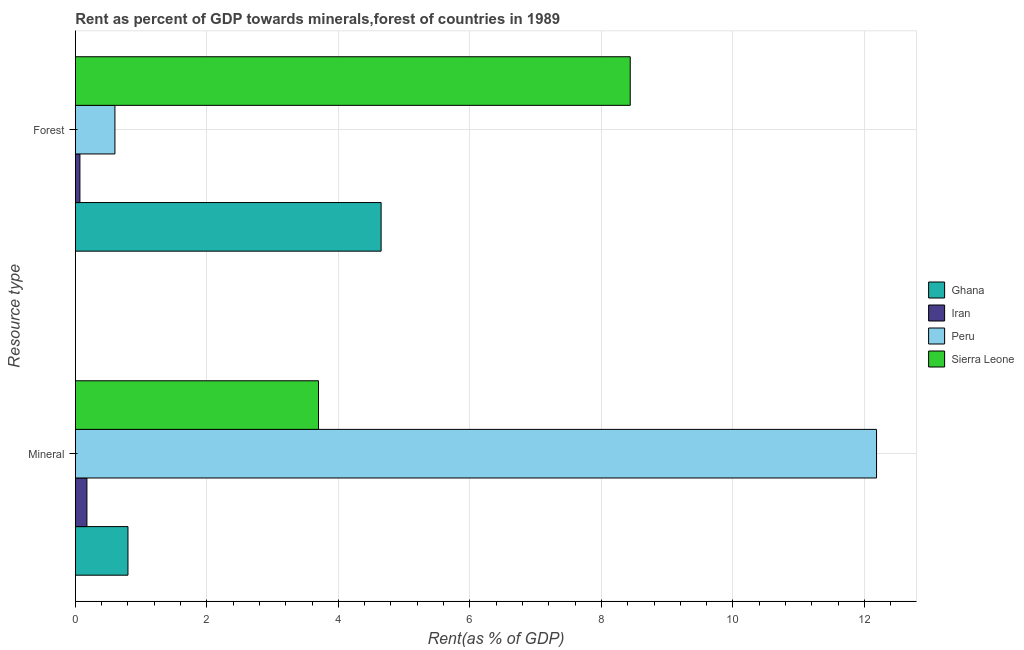How many groups of bars are there?
Provide a succinct answer. 2. What is the label of the 1st group of bars from the top?
Your answer should be very brief. Forest. What is the mineral rent in Sierra Leone?
Offer a terse response. 3.7. Across all countries, what is the maximum mineral rent?
Your answer should be very brief. 12.18. Across all countries, what is the minimum mineral rent?
Your answer should be very brief. 0.18. In which country was the forest rent minimum?
Provide a succinct answer. Iran. What is the total mineral rent in the graph?
Provide a short and direct response. 16.86. What is the difference between the forest rent in Peru and that in Iran?
Your response must be concise. 0.53. What is the difference between the forest rent in Sierra Leone and the mineral rent in Peru?
Offer a very short reply. -3.75. What is the average mineral rent per country?
Make the answer very short. 4.21. What is the difference between the forest rent and mineral rent in Peru?
Your response must be concise. -11.58. In how many countries, is the forest rent greater than 2 %?
Keep it short and to the point. 2. What is the ratio of the forest rent in Ghana to that in Sierra Leone?
Provide a succinct answer. 0.55. Is the mineral rent in Iran less than that in Ghana?
Offer a very short reply. Yes. What does the 3rd bar from the top in Mineral represents?
Your answer should be compact. Iran. What does the 2nd bar from the bottom in Mineral represents?
Keep it short and to the point. Iran. How many countries are there in the graph?
Offer a terse response. 4. What is the difference between two consecutive major ticks on the X-axis?
Keep it short and to the point. 2. Are the values on the major ticks of X-axis written in scientific E-notation?
Keep it short and to the point. No. Does the graph contain grids?
Your answer should be very brief. Yes. How many legend labels are there?
Your response must be concise. 4. What is the title of the graph?
Offer a very short reply. Rent as percent of GDP towards minerals,forest of countries in 1989. What is the label or title of the X-axis?
Your answer should be compact. Rent(as % of GDP). What is the label or title of the Y-axis?
Provide a succinct answer. Resource type. What is the Rent(as % of GDP) of Ghana in Mineral?
Offer a very short reply. 0.8. What is the Rent(as % of GDP) of Iran in Mineral?
Your response must be concise. 0.18. What is the Rent(as % of GDP) in Peru in Mineral?
Your answer should be very brief. 12.18. What is the Rent(as % of GDP) in Sierra Leone in Mineral?
Offer a very short reply. 3.7. What is the Rent(as % of GDP) of Ghana in Forest?
Offer a terse response. 4.65. What is the Rent(as % of GDP) in Iran in Forest?
Give a very brief answer. 0.07. What is the Rent(as % of GDP) in Peru in Forest?
Ensure brevity in your answer.  0.6. What is the Rent(as % of GDP) in Sierra Leone in Forest?
Your response must be concise. 8.44. Across all Resource type, what is the maximum Rent(as % of GDP) of Ghana?
Your answer should be very brief. 4.65. Across all Resource type, what is the maximum Rent(as % of GDP) of Iran?
Keep it short and to the point. 0.18. Across all Resource type, what is the maximum Rent(as % of GDP) of Peru?
Your answer should be compact. 12.18. Across all Resource type, what is the maximum Rent(as % of GDP) of Sierra Leone?
Your answer should be compact. 8.44. Across all Resource type, what is the minimum Rent(as % of GDP) in Ghana?
Ensure brevity in your answer.  0.8. Across all Resource type, what is the minimum Rent(as % of GDP) in Iran?
Offer a very short reply. 0.07. Across all Resource type, what is the minimum Rent(as % of GDP) of Peru?
Offer a very short reply. 0.6. Across all Resource type, what is the minimum Rent(as % of GDP) in Sierra Leone?
Your answer should be very brief. 3.7. What is the total Rent(as % of GDP) of Ghana in the graph?
Your response must be concise. 5.45. What is the total Rent(as % of GDP) in Iran in the graph?
Keep it short and to the point. 0.25. What is the total Rent(as % of GDP) of Peru in the graph?
Give a very brief answer. 12.79. What is the total Rent(as % of GDP) of Sierra Leone in the graph?
Make the answer very short. 12.14. What is the difference between the Rent(as % of GDP) in Ghana in Mineral and that in Forest?
Your answer should be compact. -3.85. What is the difference between the Rent(as % of GDP) in Iran in Mineral and that in Forest?
Ensure brevity in your answer.  0.11. What is the difference between the Rent(as % of GDP) of Peru in Mineral and that in Forest?
Your answer should be very brief. 11.58. What is the difference between the Rent(as % of GDP) in Sierra Leone in Mineral and that in Forest?
Your response must be concise. -4.74. What is the difference between the Rent(as % of GDP) of Ghana in Mineral and the Rent(as % of GDP) of Iran in Forest?
Give a very brief answer. 0.73. What is the difference between the Rent(as % of GDP) in Ghana in Mineral and the Rent(as % of GDP) in Peru in Forest?
Offer a very short reply. 0.2. What is the difference between the Rent(as % of GDP) of Ghana in Mineral and the Rent(as % of GDP) of Sierra Leone in Forest?
Your answer should be very brief. -7.64. What is the difference between the Rent(as % of GDP) of Iran in Mineral and the Rent(as % of GDP) of Peru in Forest?
Make the answer very short. -0.43. What is the difference between the Rent(as % of GDP) in Iran in Mineral and the Rent(as % of GDP) in Sierra Leone in Forest?
Give a very brief answer. -8.26. What is the difference between the Rent(as % of GDP) in Peru in Mineral and the Rent(as % of GDP) in Sierra Leone in Forest?
Make the answer very short. 3.75. What is the average Rent(as % of GDP) of Ghana per Resource type?
Provide a succinct answer. 2.73. What is the average Rent(as % of GDP) in Iran per Resource type?
Offer a terse response. 0.12. What is the average Rent(as % of GDP) in Peru per Resource type?
Keep it short and to the point. 6.39. What is the average Rent(as % of GDP) of Sierra Leone per Resource type?
Ensure brevity in your answer.  6.07. What is the difference between the Rent(as % of GDP) of Ghana and Rent(as % of GDP) of Iran in Mineral?
Keep it short and to the point. 0.62. What is the difference between the Rent(as % of GDP) of Ghana and Rent(as % of GDP) of Peru in Mineral?
Offer a terse response. -11.38. What is the difference between the Rent(as % of GDP) of Ghana and Rent(as % of GDP) of Sierra Leone in Mineral?
Provide a short and direct response. -2.9. What is the difference between the Rent(as % of GDP) of Iran and Rent(as % of GDP) of Peru in Mineral?
Give a very brief answer. -12.01. What is the difference between the Rent(as % of GDP) of Iran and Rent(as % of GDP) of Sierra Leone in Mineral?
Ensure brevity in your answer.  -3.52. What is the difference between the Rent(as % of GDP) in Peru and Rent(as % of GDP) in Sierra Leone in Mineral?
Give a very brief answer. 8.49. What is the difference between the Rent(as % of GDP) in Ghana and Rent(as % of GDP) in Iran in Forest?
Your response must be concise. 4.58. What is the difference between the Rent(as % of GDP) in Ghana and Rent(as % of GDP) in Peru in Forest?
Give a very brief answer. 4.05. What is the difference between the Rent(as % of GDP) in Ghana and Rent(as % of GDP) in Sierra Leone in Forest?
Ensure brevity in your answer.  -3.79. What is the difference between the Rent(as % of GDP) in Iran and Rent(as % of GDP) in Peru in Forest?
Provide a short and direct response. -0.53. What is the difference between the Rent(as % of GDP) in Iran and Rent(as % of GDP) in Sierra Leone in Forest?
Make the answer very short. -8.37. What is the difference between the Rent(as % of GDP) of Peru and Rent(as % of GDP) of Sierra Leone in Forest?
Provide a succinct answer. -7.84. What is the ratio of the Rent(as % of GDP) in Ghana in Mineral to that in Forest?
Your answer should be compact. 0.17. What is the ratio of the Rent(as % of GDP) of Iran in Mineral to that in Forest?
Ensure brevity in your answer.  2.51. What is the ratio of the Rent(as % of GDP) of Peru in Mineral to that in Forest?
Your answer should be compact. 20.22. What is the ratio of the Rent(as % of GDP) of Sierra Leone in Mineral to that in Forest?
Provide a short and direct response. 0.44. What is the difference between the highest and the second highest Rent(as % of GDP) of Ghana?
Ensure brevity in your answer.  3.85. What is the difference between the highest and the second highest Rent(as % of GDP) in Iran?
Your answer should be very brief. 0.11. What is the difference between the highest and the second highest Rent(as % of GDP) of Peru?
Make the answer very short. 11.58. What is the difference between the highest and the second highest Rent(as % of GDP) in Sierra Leone?
Keep it short and to the point. 4.74. What is the difference between the highest and the lowest Rent(as % of GDP) in Ghana?
Provide a succinct answer. 3.85. What is the difference between the highest and the lowest Rent(as % of GDP) of Iran?
Your response must be concise. 0.11. What is the difference between the highest and the lowest Rent(as % of GDP) in Peru?
Your answer should be compact. 11.58. What is the difference between the highest and the lowest Rent(as % of GDP) of Sierra Leone?
Give a very brief answer. 4.74. 